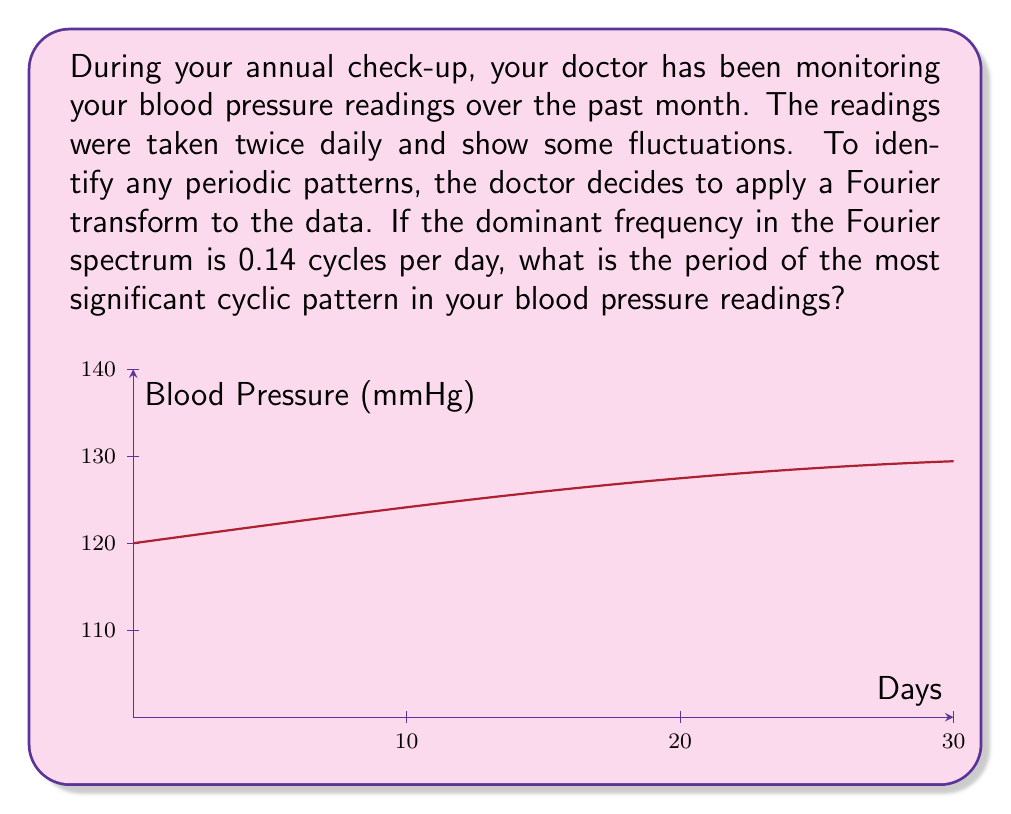Provide a solution to this math problem. Let's approach this step-by-step:

1) The Fourier transform helps identify periodic components in a signal. In this case, the signal is your blood pressure readings over time.

2) The dominant frequency in the Fourier spectrum represents the most significant cyclic pattern in the data.

3) We're given that the dominant frequency is 0.14 cycles per day.

4) The relationship between frequency ($f$) and period ($T$) is:

   $$T = \frac{1}{f}$$

5) Substituting the given frequency:

   $$T = \frac{1}{0.14} \text{ days}$$

6) Calculating:

   $$T \approx 7.14 \text{ days}$$

7) This means the most significant cyclic pattern in your blood pressure readings repeats approximately every 7.14 days.

8) For a more precise answer, we can express this as a fraction:

   $$T = \frac{1}{0.14} = \frac{100}{14} = \frac{50}{7} \text{ days}$$

Therefore, the period of the most significant cyclic pattern in your blood pressure readings is $\frac{50}{7}$ days or about 7.14 days.
Answer: $\frac{50}{7}$ days 